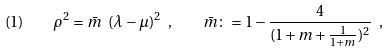<formula> <loc_0><loc_0><loc_500><loc_500>( 1 ) \quad \rho ^ { 2 } = \bar { m } \ ( \lambda - \mu ) ^ { 2 } \ , \quad \bar { m } \colon = 1 - \frac { 4 } { ( 1 + m + \frac { 1 } { 1 + m } ) ^ { 2 } } \ ,</formula> 